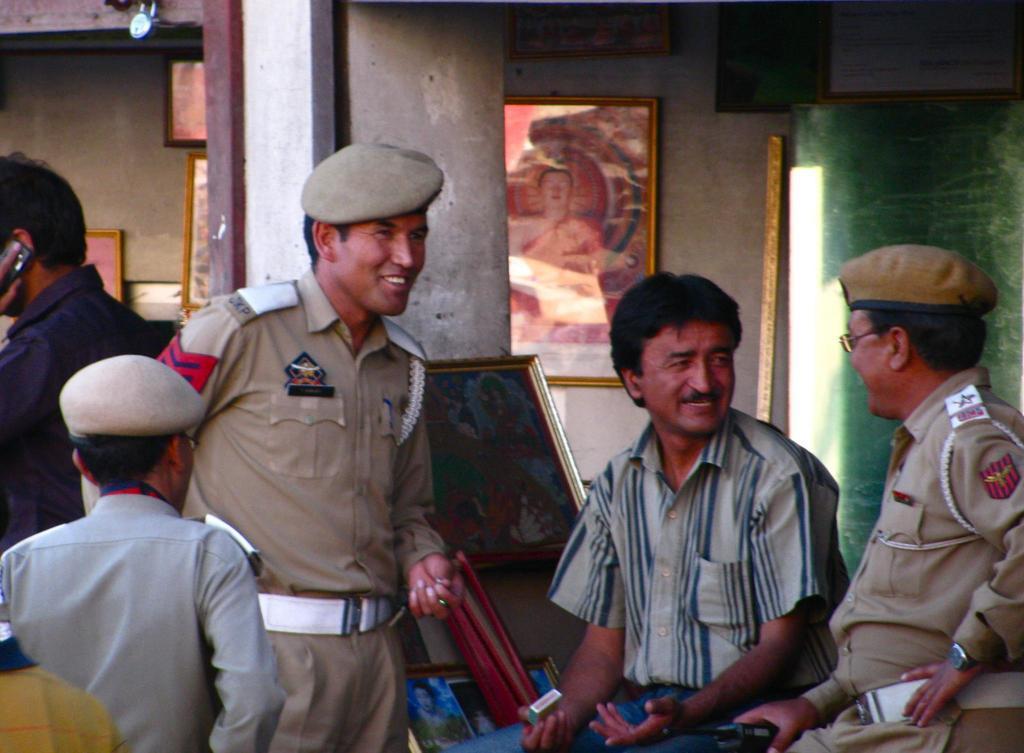Can you describe this image briefly? In this image there are a group of people some of them are wearing uniforms, and also there are some photo frames, pillar, wall. And at the top of the image there is a lock. 